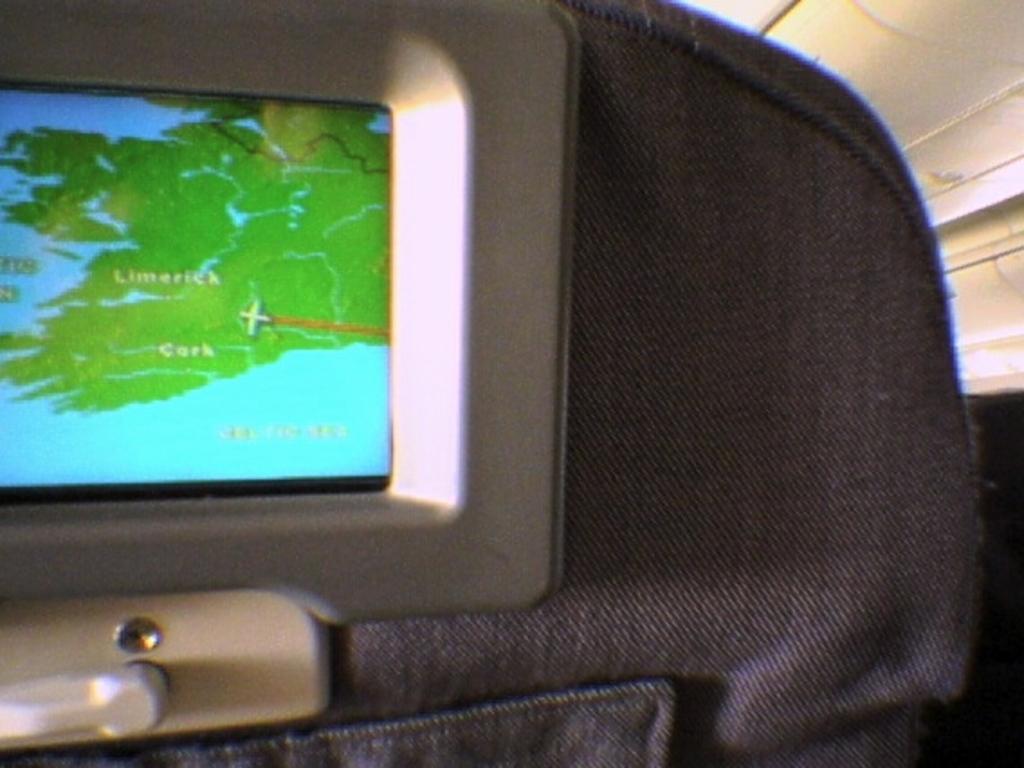Describe this image in one or two sentences. This image might be taken in the aeroplane. In this image we can see display attached to the seat. 